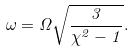<formula> <loc_0><loc_0><loc_500><loc_500>\omega = \Omega \sqrt { \frac { 3 } { \chi ^ { 2 } - 1 } } .</formula> 